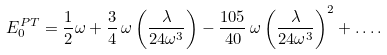<formula> <loc_0><loc_0><loc_500><loc_500>E _ { 0 } ^ { P T } = \frac { 1 } { 2 } \omega + \frac { 3 } { 4 } \, \omega \left ( \frac { \lambda } { 2 4 \omega ^ { 3 } } \right ) - \frac { 1 0 5 } { 4 0 } \, \omega \left ( \frac { \lambda } { 2 4 \omega ^ { 3 } } \right ) ^ { 2 } + \dots .</formula> 